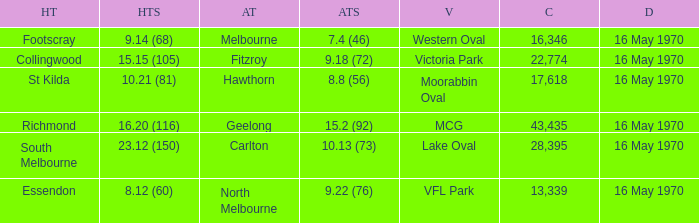Who was the away team at western oval? Melbourne. 